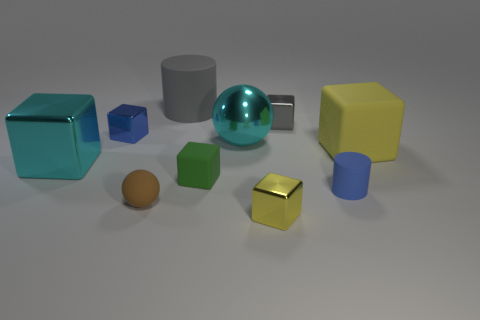How many objects are either matte objects that are behind the small blue cylinder or tiny blue metal blocks?
Your answer should be very brief. 4. There is a big metallic object that is behind the large rubber block; is it the same color as the small cylinder?
Provide a short and direct response. No. There is a blue thing that is right of the large cylinder that is behind the big rubber cube; what shape is it?
Make the answer very short. Cylinder. Is the number of tiny balls that are right of the gray cube less than the number of rubber objects that are in front of the large yellow rubber block?
Give a very brief answer. Yes. What is the size of the gray thing that is the same shape as the green rubber thing?
Your answer should be compact. Small. Is there any other thing that has the same size as the blue rubber cylinder?
Your response must be concise. Yes. How many objects are shiny things that are in front of the tiny green rubber cube or metallic things in front of the tiny gray object?
Keep it short and to the point. 4. Is the size of the blue cylinder the same as the cyan metal cube?
Ensure brevity in your answer.  No. Are there more tiny blue cylinders than tiny gray cylinders?
Keep it short and to the point. Yes. What number of other objects are the same color as the large metallic block?
Offer a terse response. 1. 